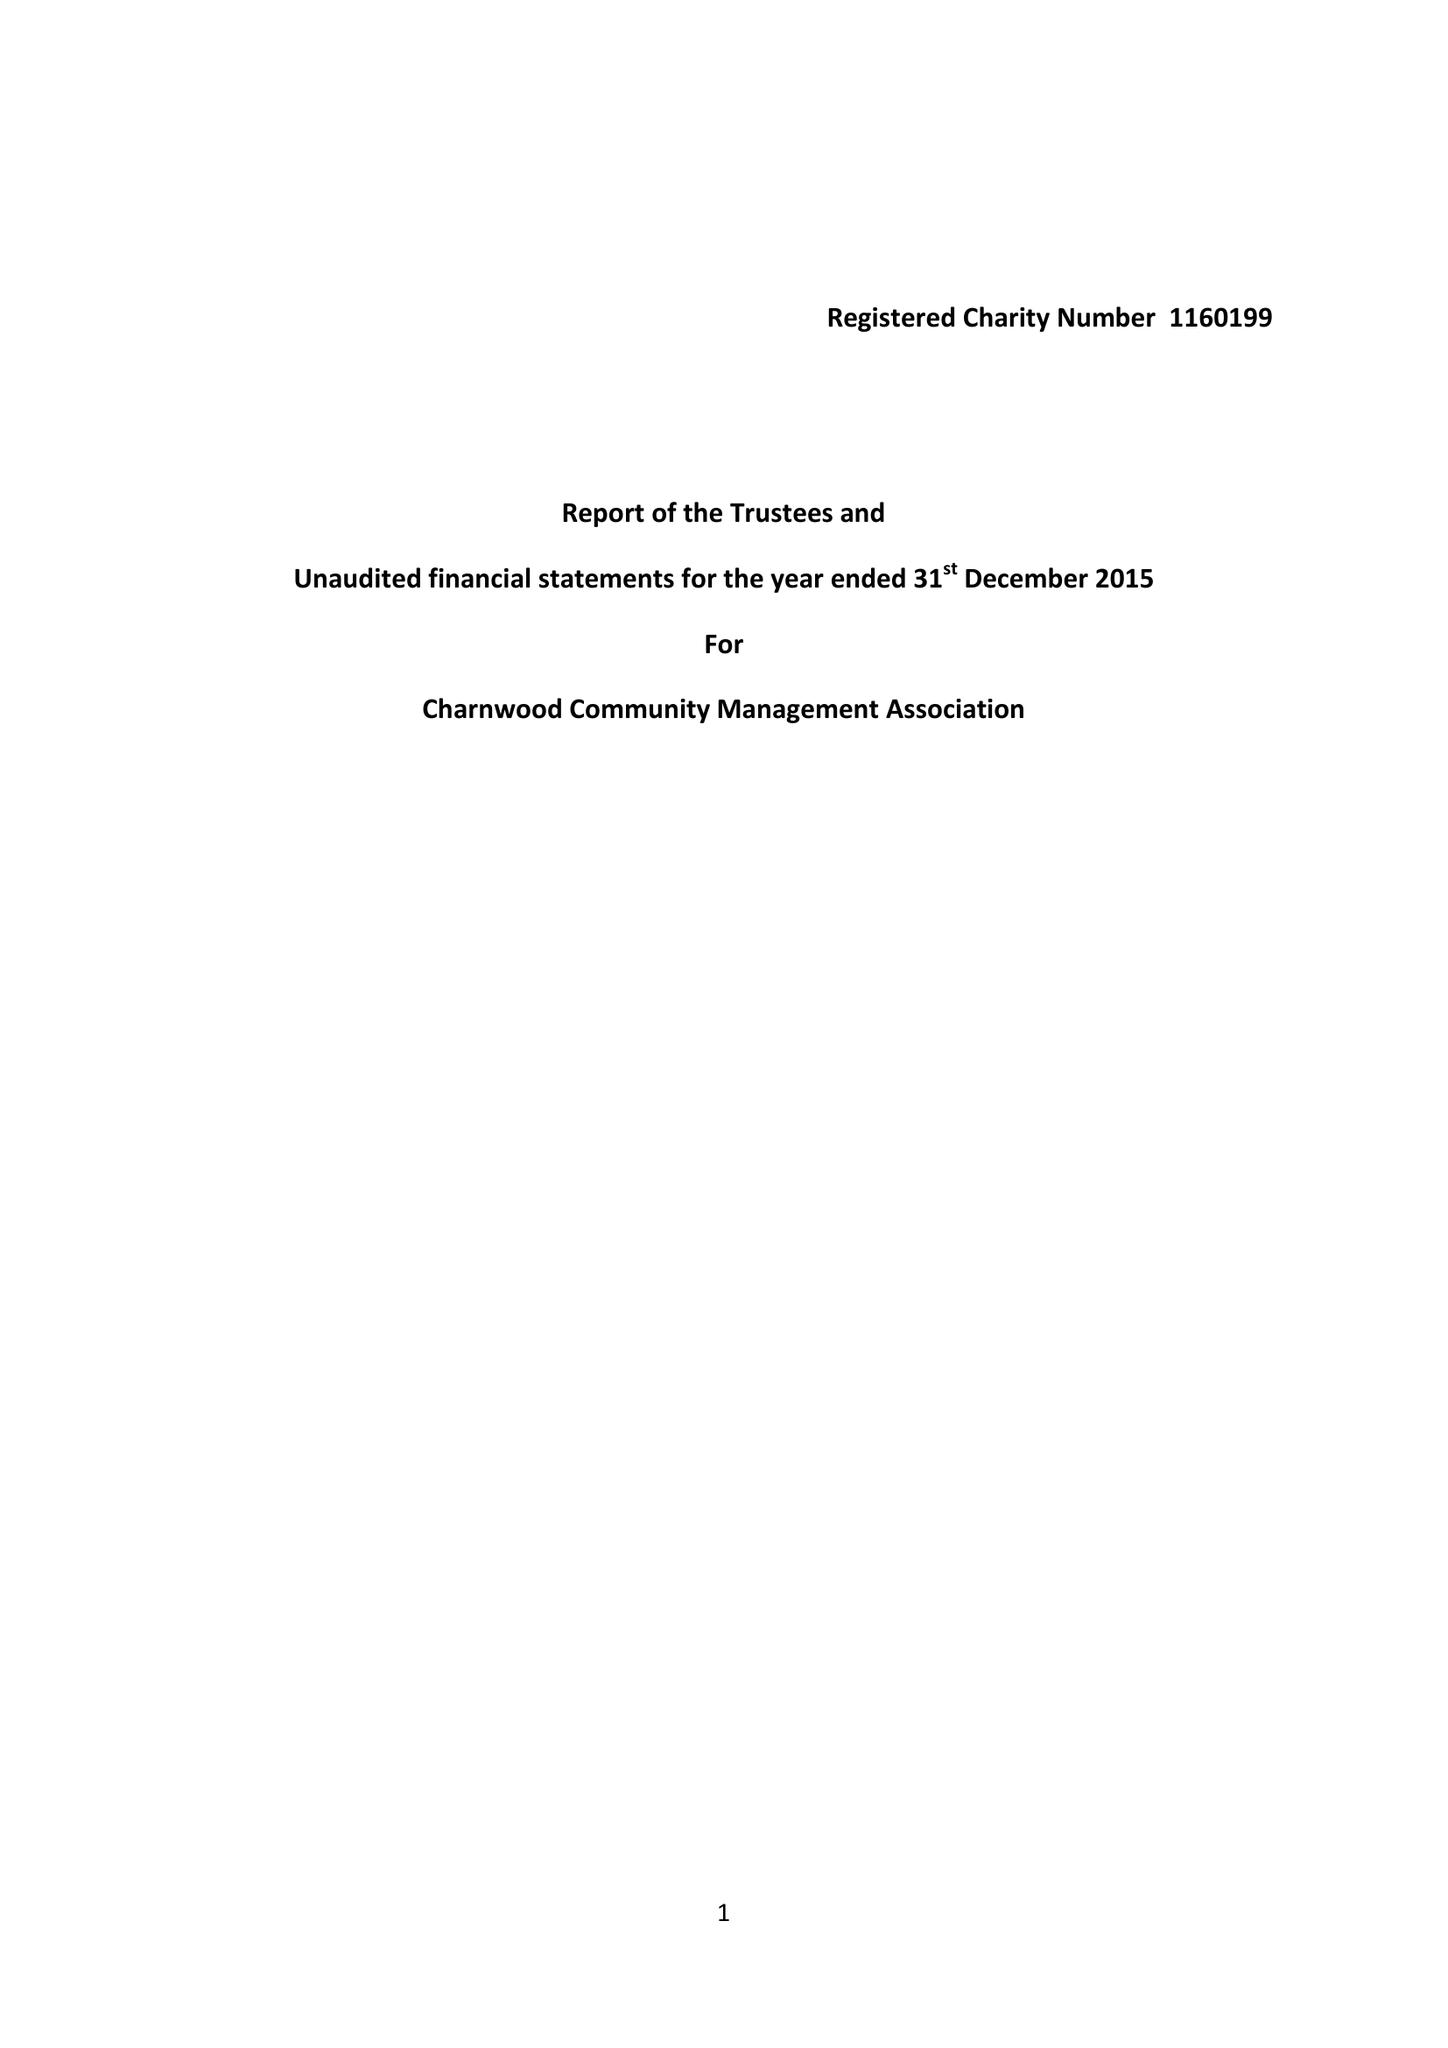What is the value for the address__postcode?
Answer the question using a single word or phrase. SG5 2HZ 